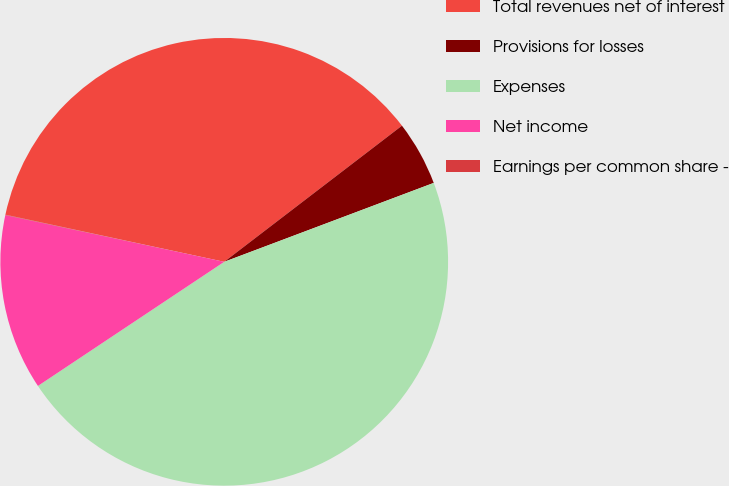<chart> <loc_0><loc_0><loc_500><loc_500><pie_chart><fcel>Total revenues net of interest<fcel>Provisions for losses<fcel>Expenses<fcel>Net income<fcel>Earnings per common share -<nl><fcel>36.22%<fcel>4.67%<fcel>46.38%<fcel>12.7%<fcel>0.03%<nl></chart> 